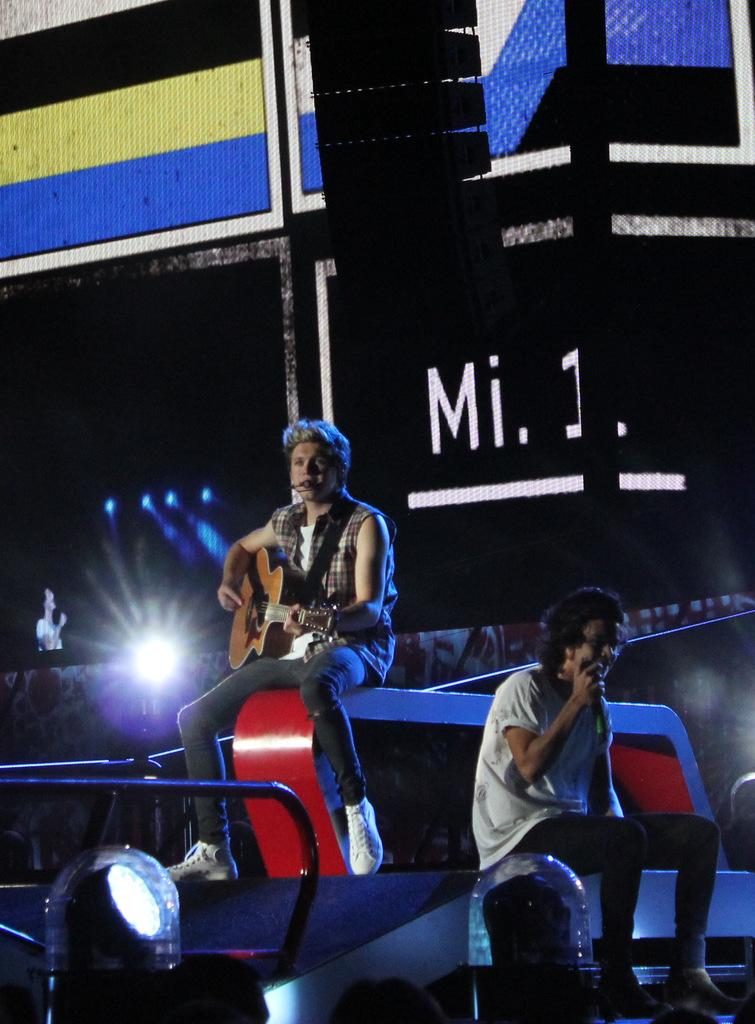How many people are in the image? There are two people in the image. What is one of the people holding? One of the people is holding a guitar. What can be seen in the image that provides illumination? There are lights visible in the image. What type of device is present in the image? There is a screen present in the image. What type of sweater is the person wearing in the image? There is no information about a sweater in the image, as the provided facts do not mention any clothing items. 